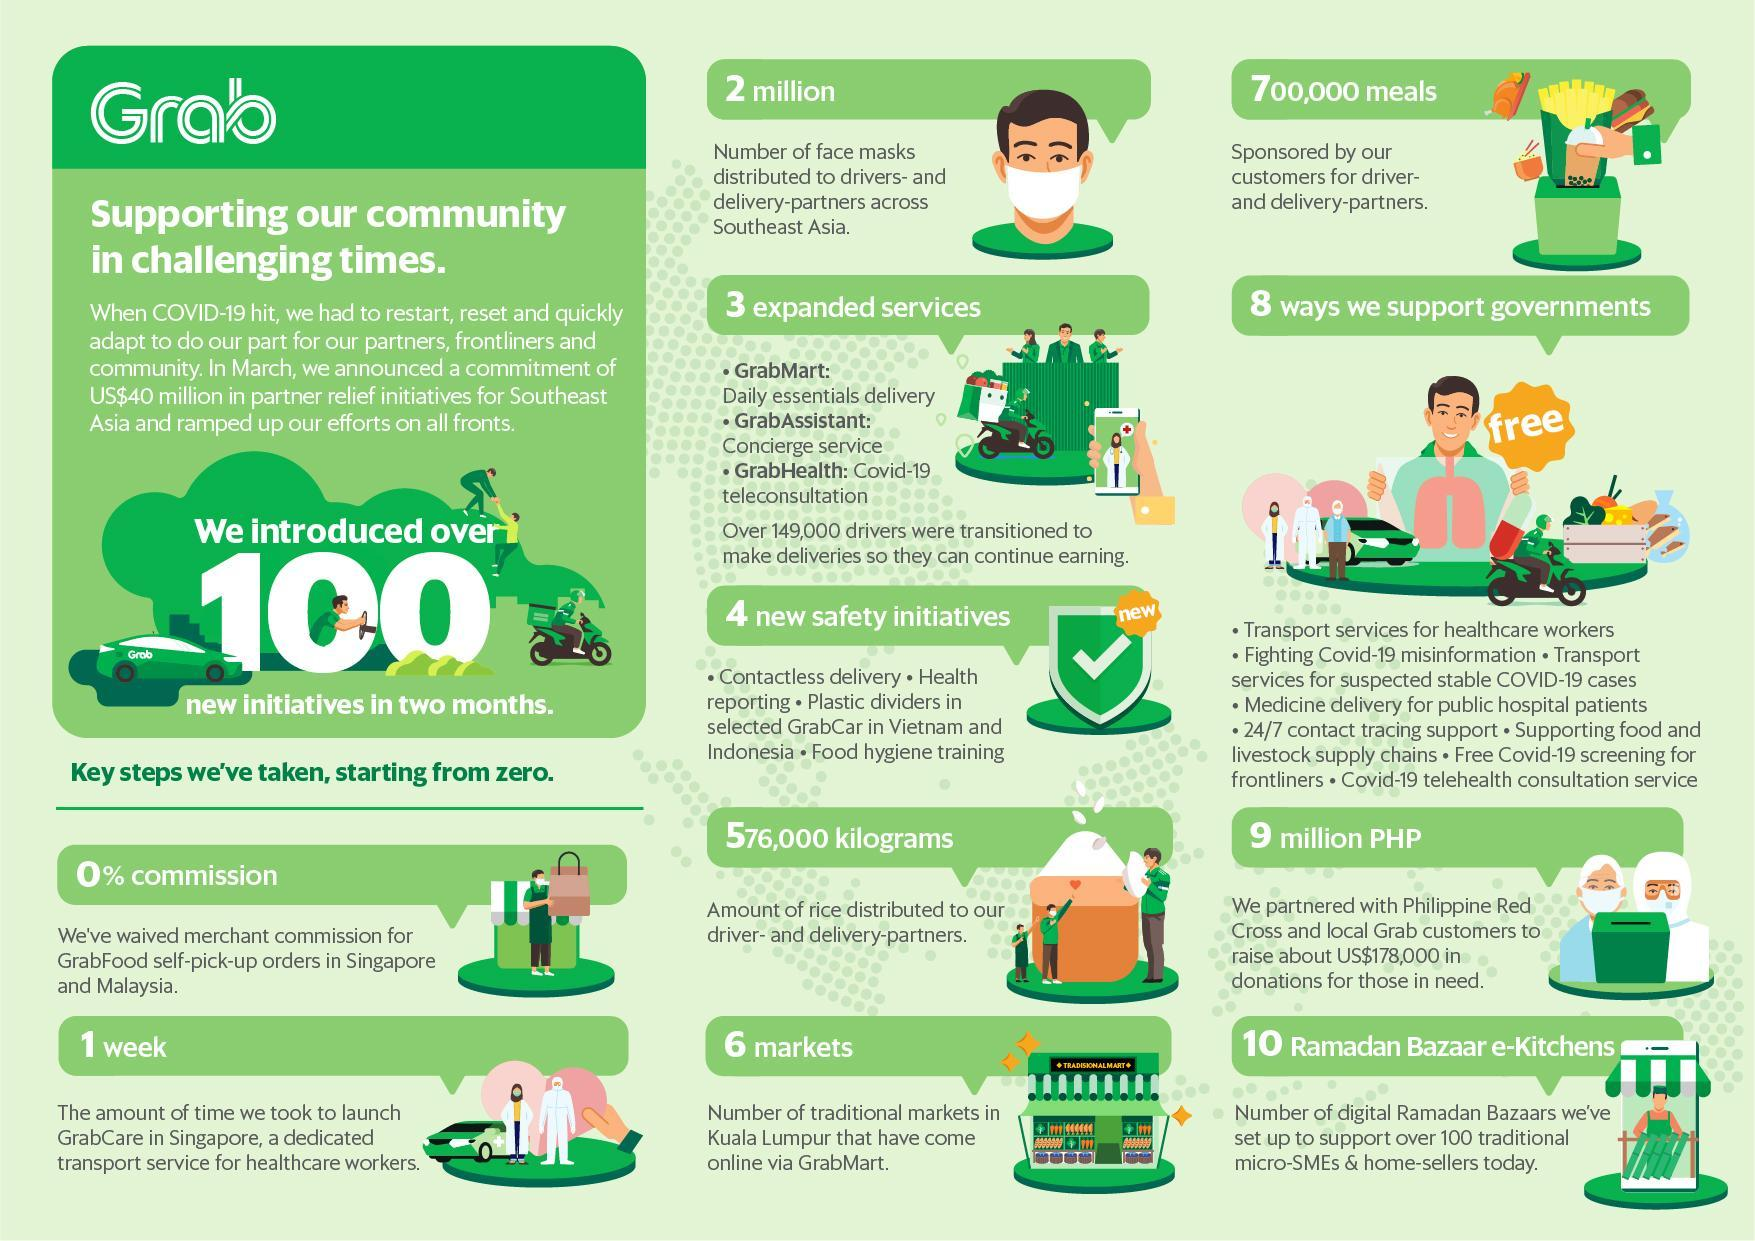What is the amount partnered with Philippine Red Cross & Local Grab customers for donations?
Answer the question with a short phrase. 9 million PHP What is the number of meals sponsored by Grab customers for driver & delivery partners? 700,000 meals What is the number of facemasks distributed to drivers & delivery partners by Grabfood across Southeast Asia? 2 million What is the Concierge service provided by Grab called as? GrabAssistant What is the Covid-19 tele-consultation service provided by Grab called as? GrabHealth What is the amount of rice distributed to Grab drivers and delivery partners? 576,000 kilograms What percentage of commission was taken by GrabFood self pickup orders in Singapore & Malaysia? 0% What is the number of traditional markets in Kuala Lumpur that have come online via Grabmart? 6 